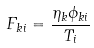Convert formula to latex. <formula><loc_0><loc_0><loc_500><loc_500>F _ { k i } = \frac { \eta _ { k } \phi _ { k i } } { T _ { i } }</formula> 